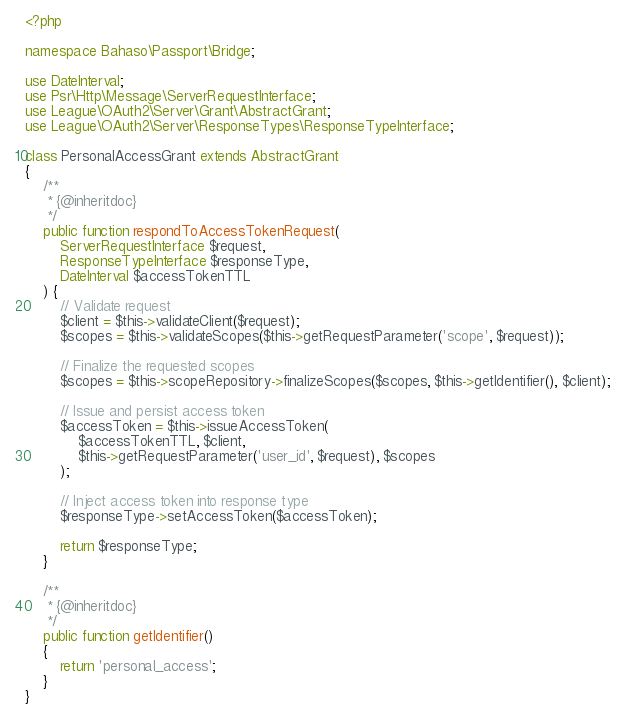Convert code to text. <code><loc_0><loc_0><loc_500><loc_500><_PHP_><?php

namespace Bahaso\Passport\Bridge;

use DateInterval;
use Psr\Http\Message\ServerRequestInterface;
use League\OAuth2\Server\Grant\AbstractGrant;
use League\OAuth2\Server\ResponseTypes\ResponseTypeInterface;

class PersonalAccessGrant extends AbstractGrant
{
    /**
     * {@inheritdoc}
     */
    public function respondToAccessTokenRequest(
        ServerRequestInterface $request,
        ResponseTypeInterface $responseType,
        DateInterval $accessTokenTTL
    ) {
        // Validate request
        $client = $this->validateClient($request);
        $scopes = $this->validateScopes($this->getRequestParameter('scope', $request));

        // Finalize the requested scopes
        $scopes = $this->scopeRepository->finalizeScopes($scopes, $this->getIdentifier(), $client);

        // Issue and persist access token
        $accessToken = $this->issueAccessToken(
            $accessTokenTTL, $client,
            $this->getRequestParameter('user_id', $request), $scopes
        );

        // Inject access token into response type
        $responseType->setAccessToken($accessToken);

        return $responseType;
    }

    /**
     * {@inheritdoc}
     */
    public function getIdentifier()
    {
        return 'personal_access';
    }
}
</code> 